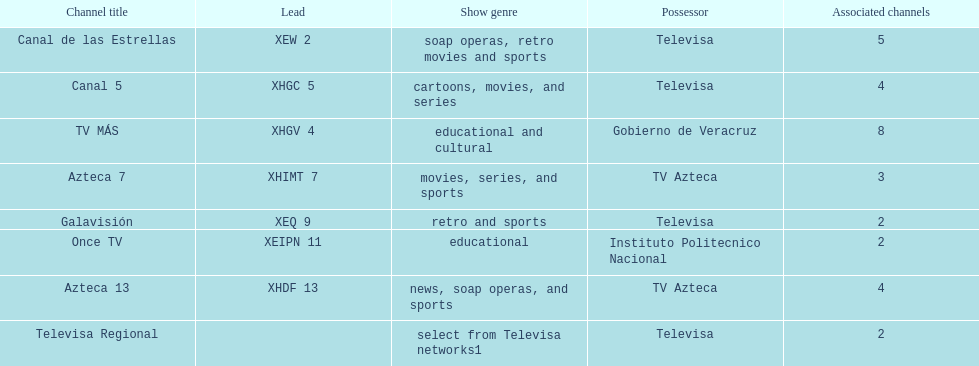Would you mind parsing the complete table? {'header': ['Channel title', 'Lead', 'Show genre', 'Possessor', 'Associated channels'], 'rows': [['Canal de las Estrellas', 'XEW 2', 'soap operas, retro movies and sports', 'Televisa', '5'], ['Canal 5', 'XHGC 5', 'cartoons, movies, and series', 'Televisa', '4'], ['TV MÁS', 'XHGV 4', 'educational and cultural', 'Gobierno de Veracruz', '8'], ['Azteca 7', 'XHIMT 7', 'movies, series, and sports', 'TV Azteca', '3'], ['Galavisión', 'XEQ 9', 'retro and sports', 'Televisa', '2'], ['Once TV', 'XEIPN 11', 'educational', 'Instituto Politecnico Nacional', '2'], ['Azteca 13', 'XHDF 13', 'news, soap operas, and sports', 'TV Azteca', '4'], ['Televisa Regional', '', 'select from Televisa networks1', 'Televisa', '2']]} Tell me the number of stations tv azteca owns. 2. 